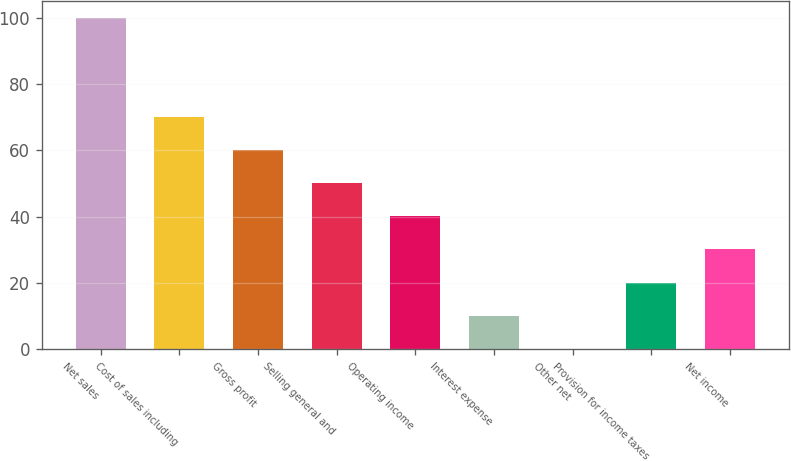Convert chart to OTSL. <chart><loc_0><loc_0><loc_500><loc_500><bar_chart><fcel>Net sales<fcel>Cost of sales including<fcel>Gross profit<fcel>Selling general and<fcel>Operating income<fcel>Interest expense<fcel>Other net<fcel>Provision for income taxes<fcel>Net income<nl><fcel>100<fcel>70.03<fcel>60.04<fcel>50.05<fcel>40.06<fcel>10.09<fcel>0.1<fcel>20.08<fcel>30.07<nl></chart> 